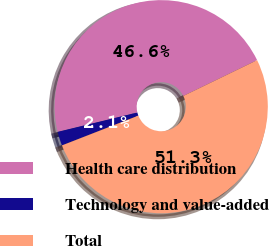<chart> <loc_0><loc_0><loc_500><loc_500><pie_chart><fcel>Health care distribution<fcel>Technology and value-added<fcel>Total<nl><fcel>46.61%<fcel>2.12%<fcel>51.27%<nl></chart> 